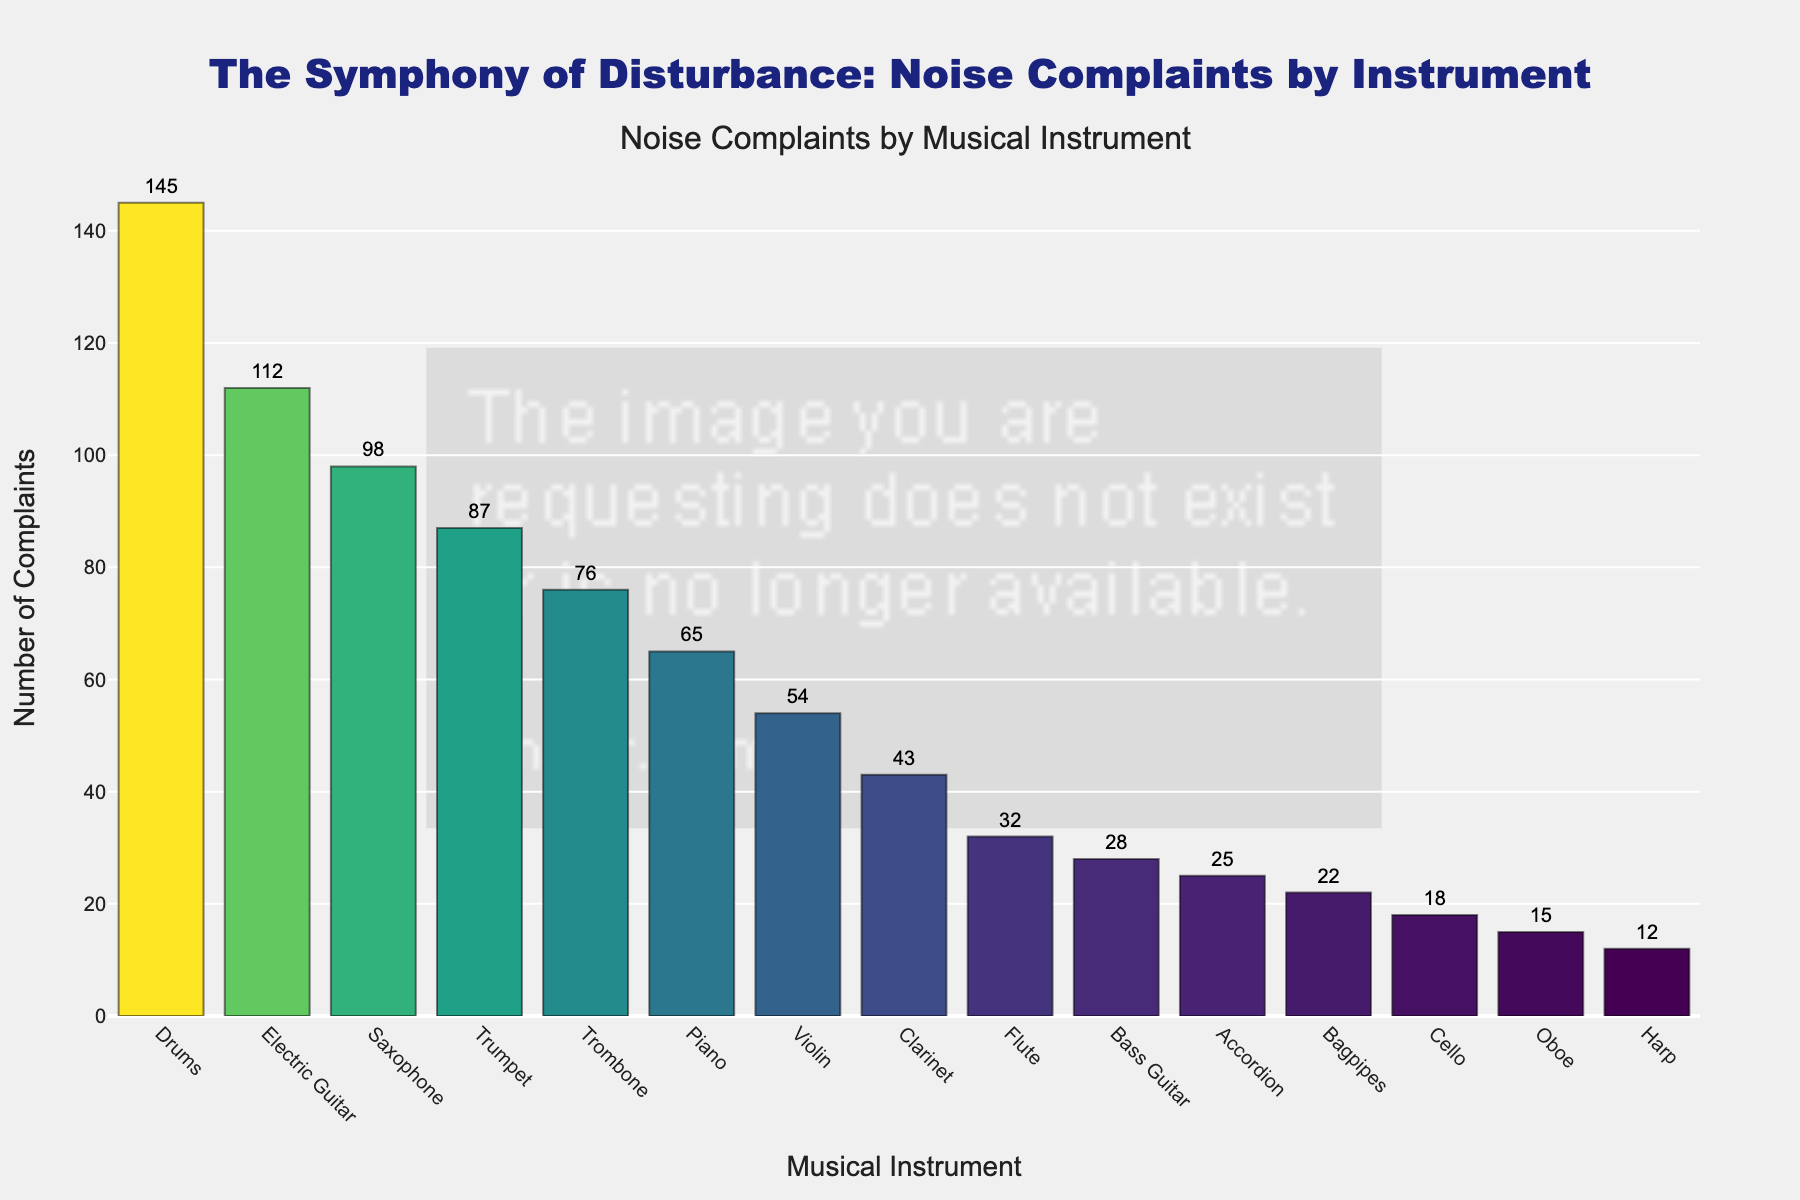Which instrument received the highest number of noise complaints? The tallest bar in the figure represents the instrument with the highest number of complaints. Observing the tallest bar, it's clear that Drums received the highest number of noise complaints.
Answer: Drums How many more complaints did the Electric Guitar receive compared to the Saxophone? Locate the bars for Electric Guitar and Saxophone. Electric Guitar has 112 complaints and Saxophone has 98 complaints. Calculate the difference between them: 112 - 98 = 14
Answer: 14 What is the total number of noise complaints received for the top three instruments? Identify the top three instruments based on the height of their bars: Drums (145), Electric Guitar (112), Saxophone (98). Sum these numbers: 145 + 112 + 98 = 355
Answer: 355 Which instrument received more complaints, the Trumpet or the Piano? Compare the heights of the bars for Trumpet and Piano. The bar for Trumpet (87) is taller than the bar for Piano (65). Therefore, the Trumpet received more complaints.
Answer: Trumpet What is the combined number of complaints for Brass instruments (Trumpet, Trombone, and Tuba)? Locate the bars for Trumpet (87) and Trombone (76). Note that Tuba is not present in the data. Then sum the complaints: 87 + 76 = 163.
Answer: 163 What is the average number of complaints received by the Drum, Saxophone, and Piano? Identify the complaints for Drum, Saxophone, and Piano, which are 145, 98, and 65 respectively. Sum these numbers: 145 + 98 + 65 = 308. Then, divide by 3: 308 / 3 ≈ 102.67
Answer: 102.67 Which instrument received fewer complaints, the Violin or the Cello? Compare the heights of the bars for Violin and Cello. The bar for Cello (18) is shorter than the bar for Violin (54). Therefore, the Cello received fewer complaints.
Answer: Cello What instrument received the least number of complaints? The shortest bar represents the instrument with the least number of complaints. Identify the shortest bar, which corresponds to the Harp with 12 complaints.
Answer: Harp How does the number of complaints for the Accordion compare to the Violin? Compare the heights of the bars for Accordion and Violin. The bar for Accordion (25) is shorter than the bar for Violin (54), indicating that the Accordion received fewer complaints.
Answer: Accordion 